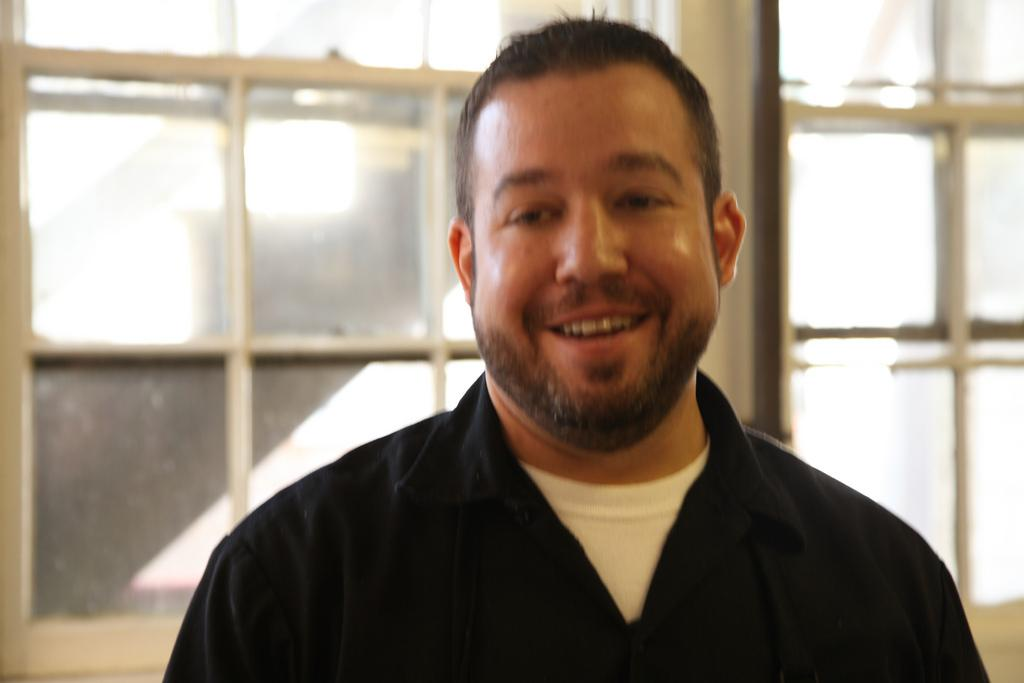Who or what is present in the image? There is a person in the image. What architectural feature can be seen in the image? There are windows visible in the image. What type of fruit is the person holding in the image? There is no fruit present in the image; only a person and windows are visible. What type of collar is the person wearing in the image? There is no collar visible in the image, as the person is not wearing any clothing or accessories. 